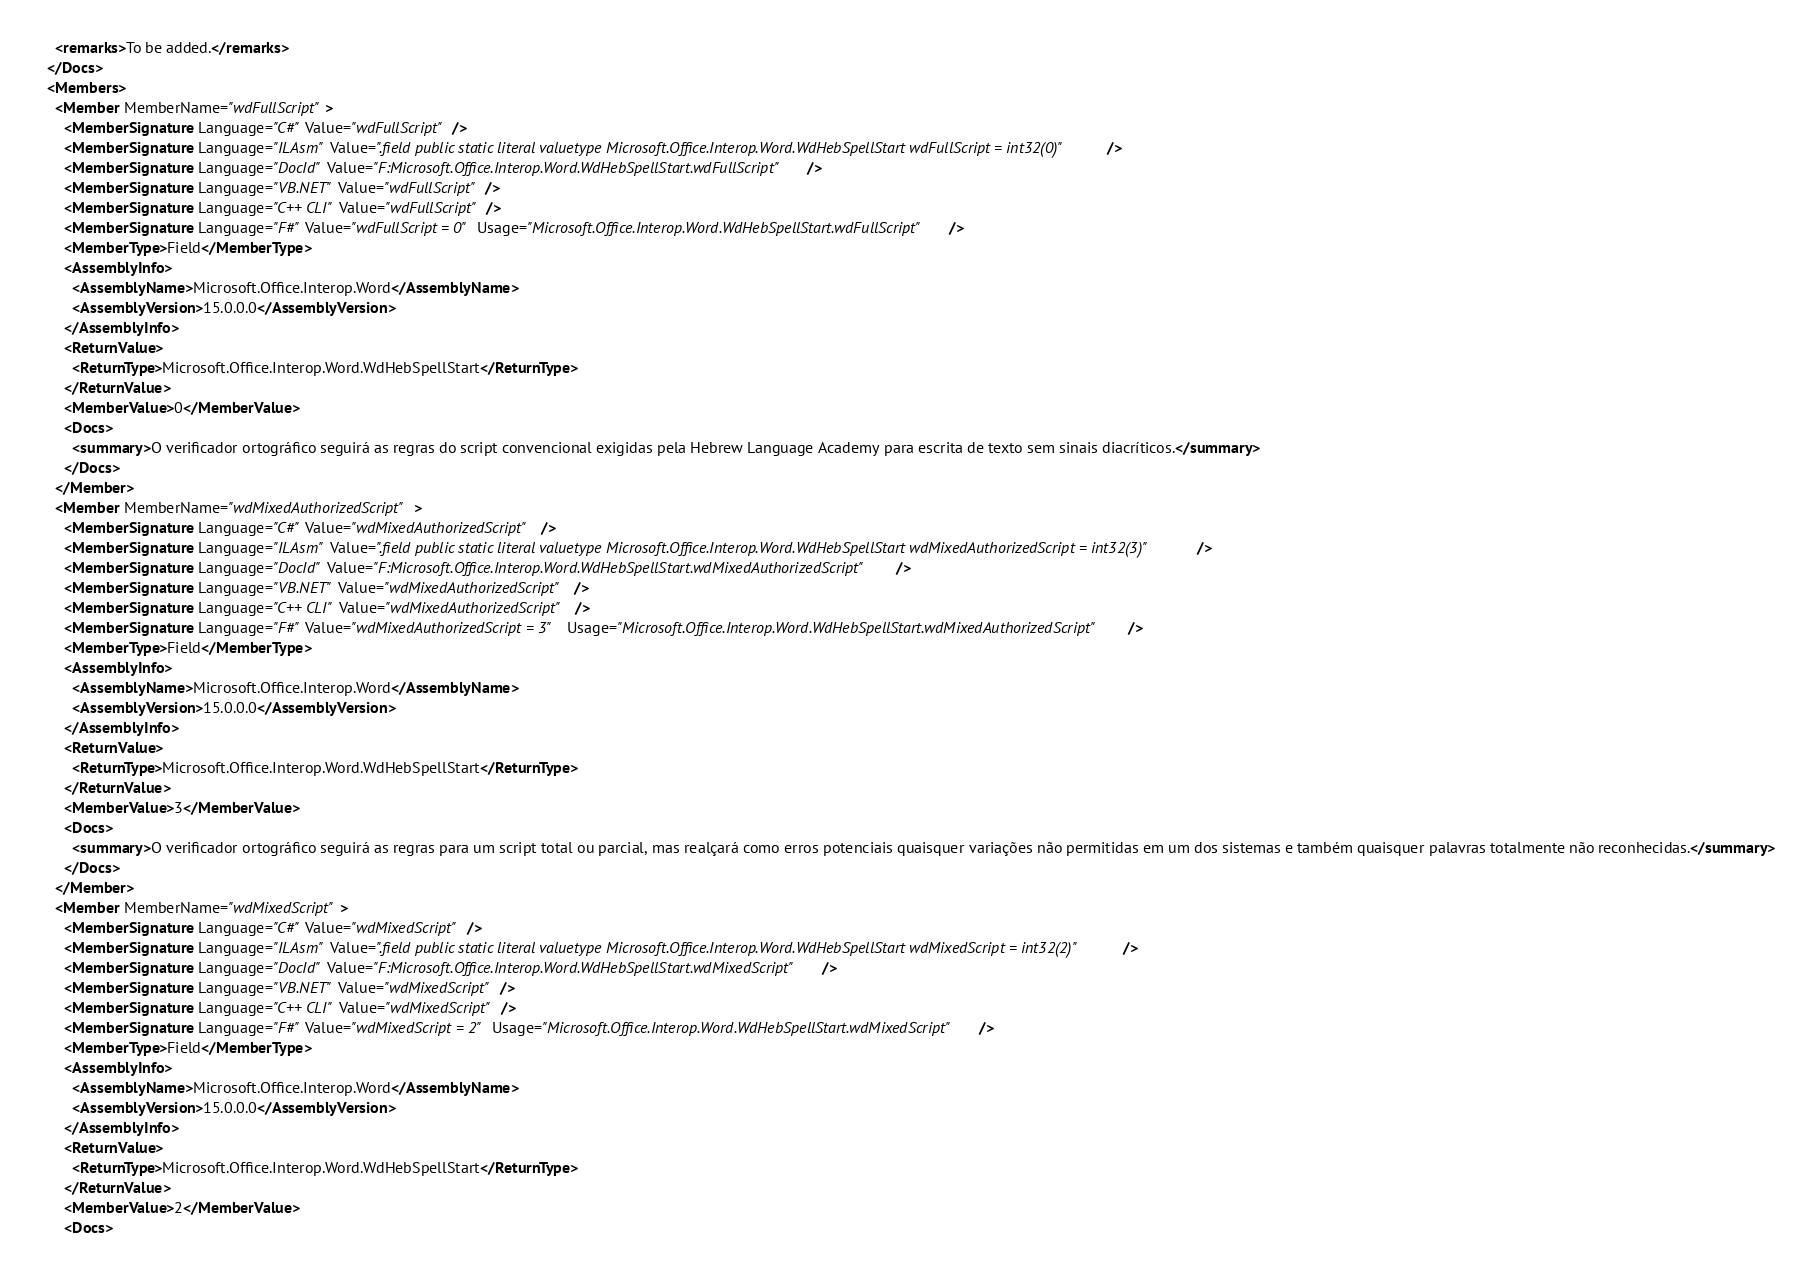Convert code to text. <code><loc_0><loc_0><loc_500><loc_500><_XML_>    <remarks>To be added.</remarks>
  </Docs>
  <Members>
    <Member MemberName="wdFullScript">
      <MemberSignature Language="C#" Value="wdFullScript" />
      <MemberSignature Language="ILAsm" Value=".field public static literal valuetype Microsoft.Office.Interop.Word.WdHebSpellStart wdFullScript = int32(0)" />
      <MemberSignature Language="DocId" Value="F:Microsoft.Office.Interop.Word.WdHebSpellStart.wdFullScript" />
      <MemberSignature Language="VB.NET" Value="wdFullScript" />
      <MemberSignature Language="C++ CLI" Value="wdFullScript" />
      <MemberSignature Language="F#" Value="wdFullScript = 0" Usage="Microsoft.Office.Interop.Word.WdHebSpellStart.wdFullScript" />
      <MemberType>Field</MemberType>
      <AssemblyInfo>
        <AssemblyName>Microsoft.Office.Interop.Word</AssemblyName>
        <AssemblyVersion>15.0.0.0</AssemblyVersion>
      </AssemblyInfo>
      <ReturnValue>
        <ReturnType>Microsoft.Office.Interop.Word.WdHebSpellStart</ReturnType>
      </ReturnValue>
      <MemberValue>0</MemberValue>
      <Docs>
        <summary>O verificador ortográfico seguirá as regras do script convencional exigidas pela Hebrew Language Academy para escrita de texto sem sinais diacríticos.</summary>
      </Docs>
    </Member>
    <Member MemberName="wdMixedAuthorizedScript">
      <MemberSignature Language="C#" Value="wdMixedAuthorizedScript" />
      <MemberSignature Language="ILAsm" Value=".field public static literal valuetype Microsoft.Office.Interop.Word.WdHebSpellStart wdMixedAuthorizedScript = int32(3)" />
      <MemberSignature Language="DocId" Value="F:Microsoft.Office.Interop.Word.WdHebSpellStart.wdMixedAuthorizedScript" />
      <MemberSignature Language="VB.NET" Value="wdMixedAuthorizedScript" />
      <MemberSignature Language="C++ CLI" Value="wdMixedAuthorizedScript" />
      <MemberSignature Language="F#" Value="wdMixedAuthorizedScript = 3" Usage="Microsoft.Office.Interop.Word.WdHebSpellStart.wdMixedAuthorizedScript" />
      <MemberType>Field</MemberType>
      <AssemblyInfo>
        <AssemblyName>Microsoft.Office.Interop.Word</AssemblyName>
        <AssemblyVersion>15.0.0.0</AssemblyVersion>
      </AssemblyInfo>
      <ReturnValue>
        <ReturnType>Microsoft.Office.Interop.Word.WdHebSpellStart</ReturnType>
      </ReturnValue>
      <MemberValue>3</MemberValue>
      <Docs>
        <summary>O verificador ortográfico seguirá as regras para um script total ou parcial, mas realçará como erros potenciais quaisquer variações não permitidas em um dos sistemas e também quaisquer palavras totalmente não reconhecidas.</summary>
      </Docs>
    </Member>
    <Member MemberName="wdMixedScript">
      <MemberSignature Language="C#" Value="wdMixedScript" />
      <MemberSignature Language="ILAsm" Value=".field public static literal valuetype Microsoft.Office.Interop.Word.WdHebSpellStart wdMixedScript = int32(2)" />
      <MemberSignature Language="DocId" Value="F:Microsoft.Office.Interop.Word.WdHebSpellStart.wdMixedScript" />
      <MemberSignature Language="VB.NET" Value="wdMixedScript" />
      <MemberSignature Language="C++ CLI" Value="wdMixedScript" />
      <MemberSignature Language="F#" Value="wdMixedScript = 2" Usage="Microsoft.Office.Interop.Word.WdHebSpellStart.wdMixedScript" />
      <MemberType>Field</MemberType>
      <AssemblyInfo>
        <AssemblyName>Microsoft.Office.Interop.Word</AssemblyName>
        <AssemblyVersion>15.0.0.0</AssemblyVersion>
      </AssemblyInfo>
      <ReturnValue>
        <ReturnType>Microsoft.Office.Interop.Word.WdHebSpellStart</ReturnType>
      </ReturnValue>
      <MemberValue>2</MemberValue>
      <Docs></code> 